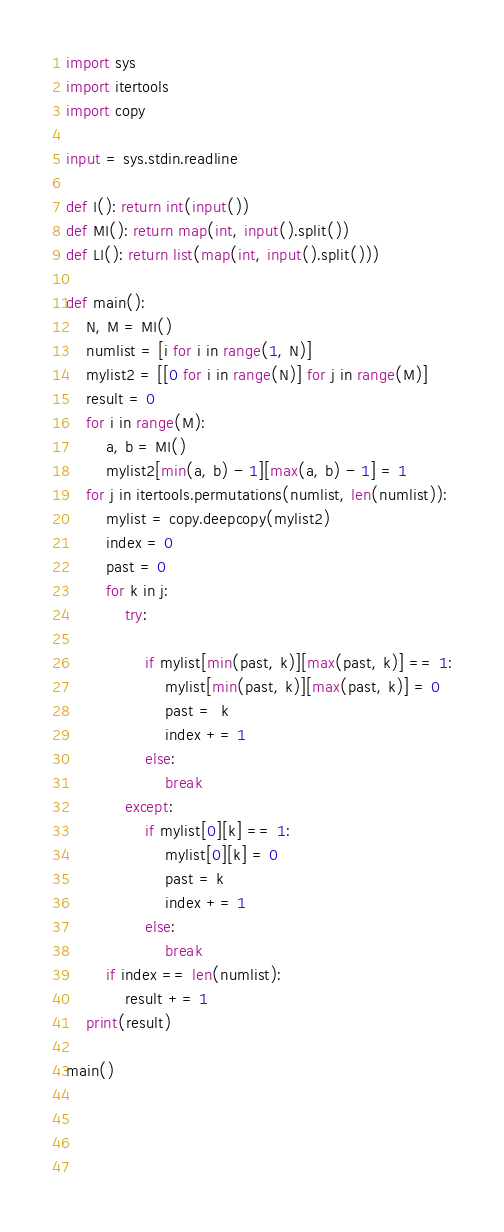<code> <loc_0><loc_0><loc_500><loc_500><_Python_>import sys
import itertools
import copy

input = sys.stdin.readline

def I(): return int(input())
def MI(): return map(int, input().split())
def LI(): return list(map(int, input().split()))

def main():
    N, M = MI()
    numlist = [i for i in range(1, N)]
    mylist2 = [[0 for i in range(N)] for j in range(M)]
    result = 0
    for i in range(M):
        a, b = MI()
        mylist2[min(a, b) - 1][max(a, b) - 1] = 1
    for j in itertools.permutations(numlist, len(numlist)):
        mylist = copy.deepcopy(mylist2)
        index = 0
        past = 0
        for k in j:
            try:
                
                if mylist[min(past, k)][max(past, k)] == 1:
                    mylist[min(past, k)][max(past, k)] = 0
                    past =  k
                    index += 1
                else:
                    break
            except:
                if mylist[0][k] == 1:
                    mylist[0][k] = 0
                    past = k
                    index += 1
                else:
                    break
        if index == len(numlist):
            result += 1
    print(result)
    
main()
                        
                    
        
    </code> 